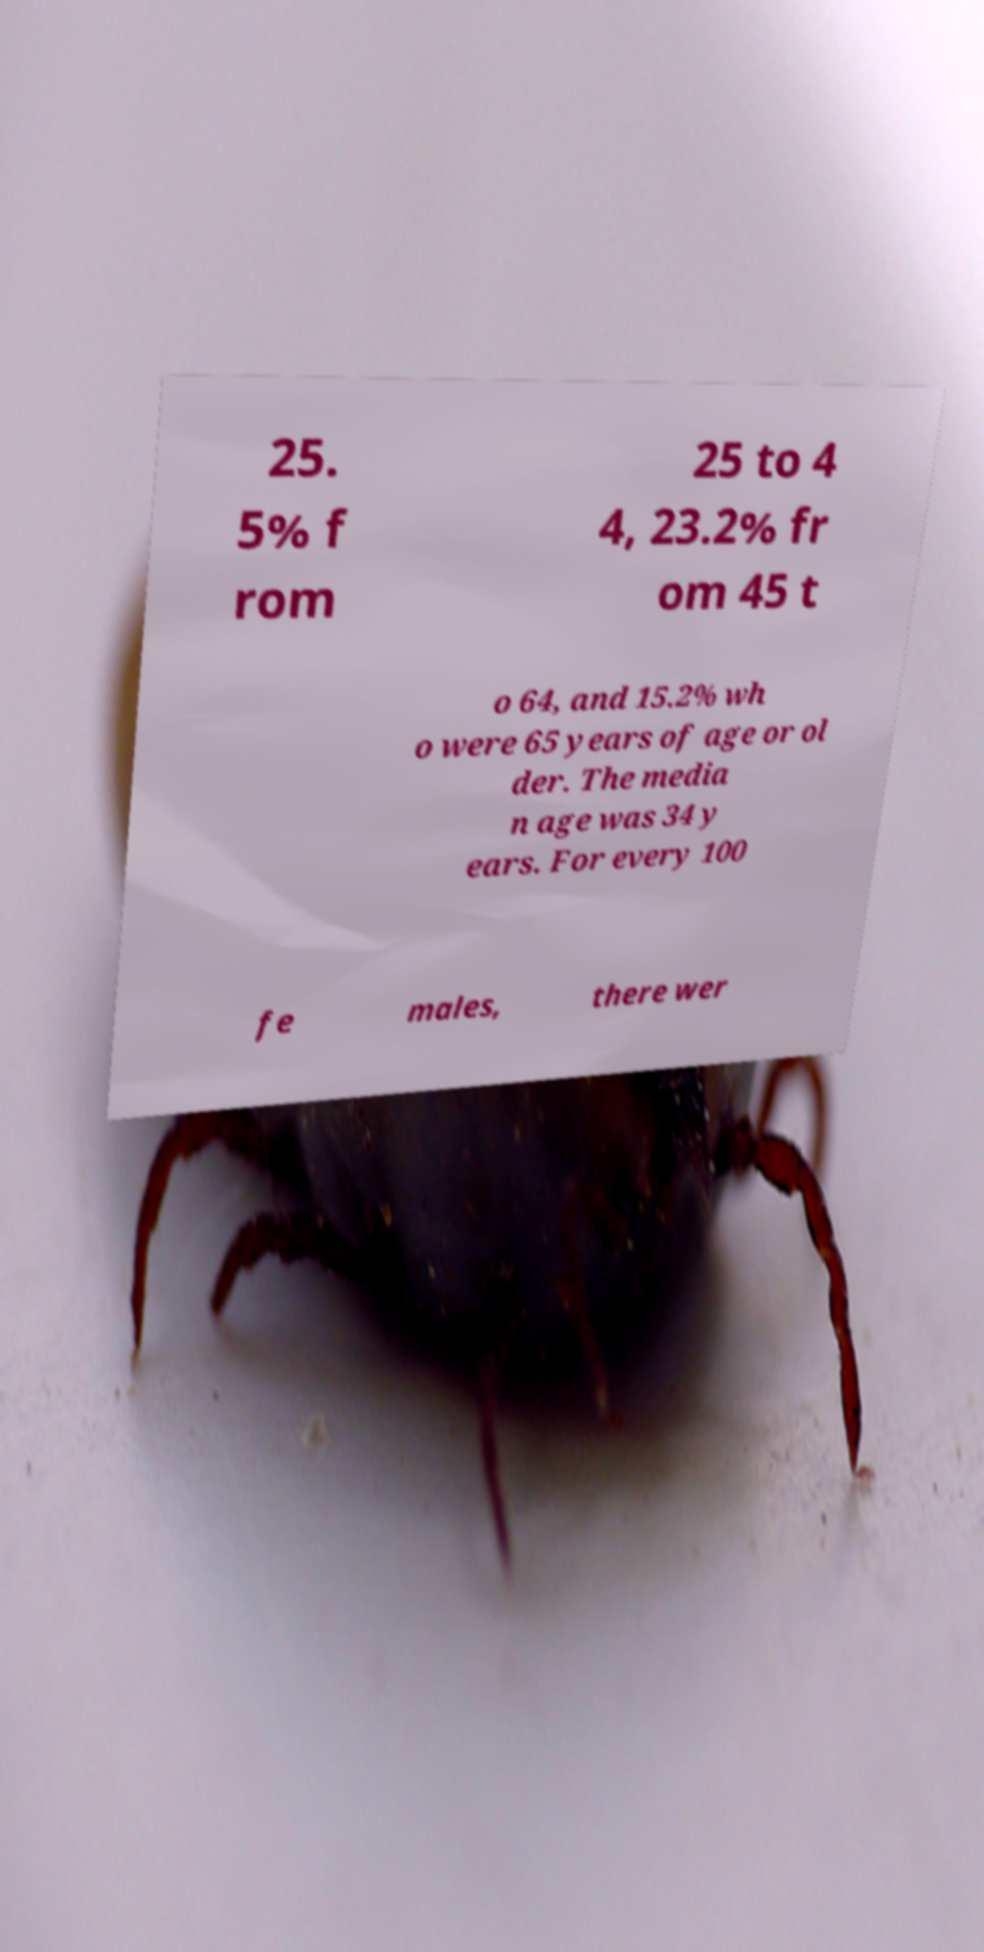Could you extract and type out the text from this image? 25. 5% f rom 25 to 4 4, 23.2% fr om 45 t o 64, and 15.2% wh o were 65 years of age or ol der. The media n age was 34 y ears. For every 100 fe males, there wer 